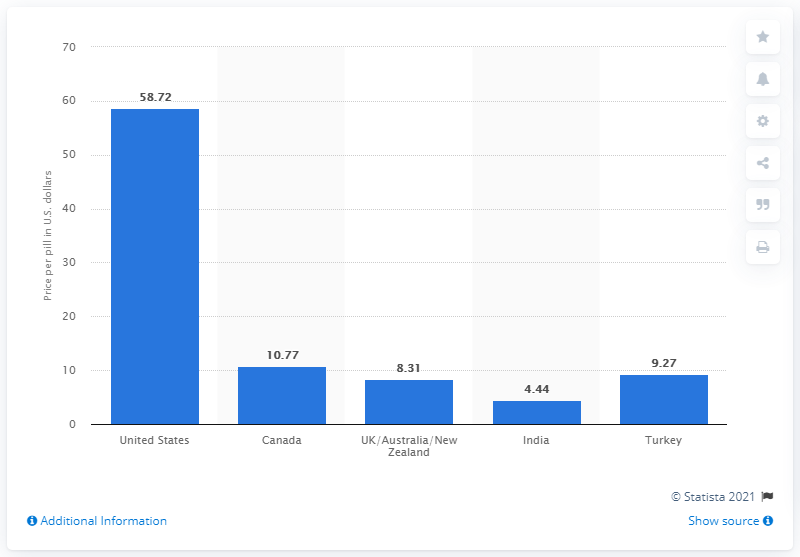Mention a couple of crucial points in this snapshot. The United States has the highest price disparity among countries. The cost of a Viagra pill in India was approximately 4.44 rupees. In the second quarter of 2017, the cost of a single Viagra pill in the United States was $58.72. The sum of the three dipasrities is 22.02.. 